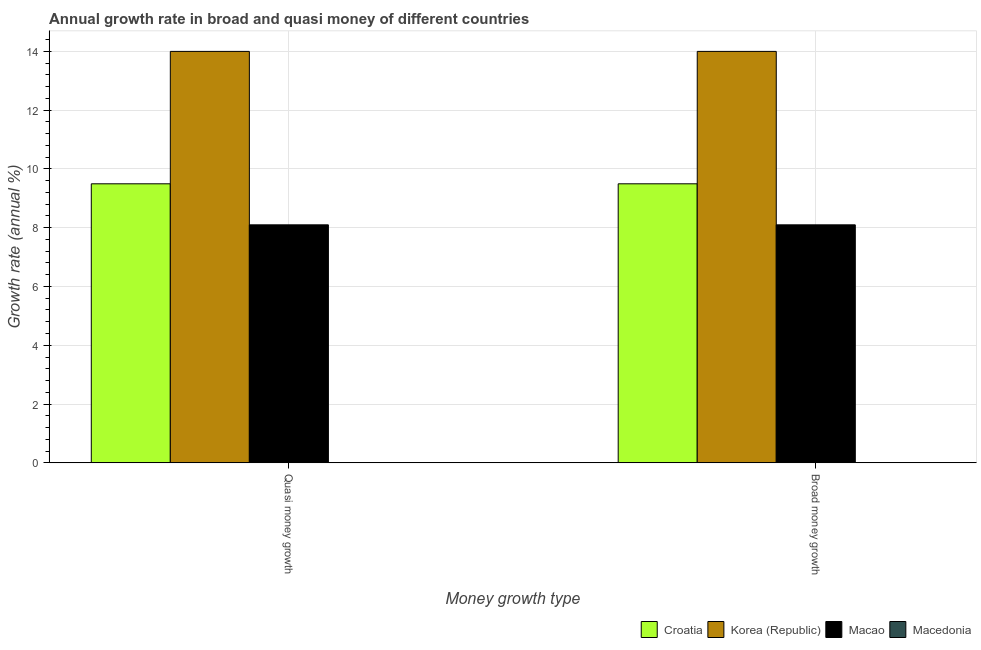How many different coloured bars are there?
Your response must be concise. 3. Are the number of bars per tick equal to the number of legend labels?
Ensure brevity in your answer.  No. Are the number of bars on each tick of the X-axis equal?
Your answer should be very brief. Yes. How many bars are there on the 2nd tick from the left?
Make the answer very short. 3. What is the label of the 1st group of bars from the left?
Ensure brevity in your answer.  Quasi money growth. What is the annual growth rate in quasi money in Macao?
Provide a succinct answer. 8.1. Across all countries, what is the maximum annual growth rate in quasi money?
Provide a succinct answer. 14. Across all countries, what is the minimum annual growth rate in quasi money?
Your answer should be compact. 0. What is the total annual growth rate in quasi money in the graph?
Offer a very short reply. 31.59. What is the difference between the annual growth rate in quasi money in Korea (Republic) and that in Macao?
Provide a succinct answer. 5.9. What is the difference between the annual growth rate in quasi money in Croatia and the annual growth rate in broad money in Macedonia?
Keep it short and to the point. 9.49. What is the average annual growth rate in quasi money per country?
Offer a terse response. 7.9. In how many countries, is the annual growth rate in broad money greater than 4.4 %?
Keep it short and to the point. 3. What is the ratio of the annual growth rate in broad money in Macao to that in Croatia?
Ensure brevity in your answer.  0.85. Is the annual growth rate in quasi money in Macao less than that in Korea (Republic)?
Keep it short and to the point. Yes. How many bars are there?
Offer a terse response. 6. What is the difference between two consecutive major ticks on the Y-axis?
Offer a terse response. 2. Does the graph contain any zero values?
Keep it short and to the point. Yes. How many legend labels are there?
Offer a very short reply. 4. How are the legend labels stacked?
Your response must be concise. Horizontal. What is the title of the graph?
Provide a succinct answer. Annual growth rate in broad and quasi money of different countries. Does "Cyprus" appear as one of the legend labels in the graph?
Ensure brevity in your answer.  No. What is the label or title of the X-axis?
Offer a terse response. Money growth type. What is the label or title of the Y-axis?
Your answer should be compact. Growth rate (annual %). What is the Growth rate (annual %) of Croatia in Quasi money growth?
Offer a terse response. 9.49. What is the Growth rate (annual %) of Korea (Republic) in Quasi money growth?
Give a very brief answer. 14. What is the Growth rate (annual %) in Macao in Quasi money growth?
Your answer should be compact. 8.1. What is the Growth rate (annual %) of Macedonia in Quasi money growth?
Ensure brevity in your answer.  0. What is the Growth rate (annual %) of Croatia in Broad money growth?
Give a very brief answer. 9.49. What is the Growth rate (annual %) of Korea (Republic) in Broad money growth?
Provide a succinct answer. 14. What is the Growth rate (annual %) of Macao in Broad money growth?
Provide a succinct answer. 8.1. What is the Growth rate (annual %) of Macedonia in Broad money growth?
Make the answer very short. 0. Across all Money growth type, what is the maximum Growth rate (annual %) in Croatia?
Your response must be concise. 9.49. Across all Money growth type, what is the maximum Growth rate (annual %) in Korea (Republic)?
Your answer should be compact. 14. Across all Money growth type, what is the maximum Growth rate (annual %) of Macao?
Give a very brief answer. 8.1. Across all Money growth type, what is the minimum Growth rate (annual %) of Croatia?
Offer a very short reply. 9.49. Across all Money growth type, what is the minimum Growth rate (annual %) of Korea (Republic)?
Provide a succinct answer. 14. Across all Money growth type, what is the minimum Growth rate (annual %) in Macao?
Provide a succinct answer. 8.1. What is the total Growth rate (annual %) in Croatia in the graph?
Keep it short and to the point. 18.99. What is the total Growth rate (annual %) of Korea (Republic) in the graph?
Give a very brief answer. 28. What is the total Growth rate (annual %) of Macao in the graph?
Ensure brevity in your answer.  16.2. What is the total Growth rate (annual %) in Macedonia in the graph?
Give a very brief answer. 0. What is the difference between the Growth rate (annual %) in Korea (Republic) in Quasi money growth and that in Broad money growth?
Offer a very short reply. 0. What is the difference between the Growth rate (annual %) of Croatia in Quasi money growth and the Growth rate (annual %) of Korea (Republic) in Broad money growth?
Give a very brief answer. -4.51. What is the difference between the Growth rate (annual %) in Croatia in Quasi money growth and the Growth rate (annual %) in Macao in Broad money growth?
Your response must be concise. 1.4. What is the difference between the Growth rate (annual %) of Korea (Republic) in Quasi money growth and the Growth rate (annual %) of Macao in Broad money growth?
Your answer should be compact. 5.9. What is the average Growth rate (annual %) in Croatia per Money growth type?
Make the answer very short. 9.49. What is the average Growth rate (annual %) in Korea (Republic) per Money growth type?
Your answer should be very brief. 14. What is the average Growth rate (annual %) of Macao per Money growth type?
Ensure brevity in your answer.  8.1. What is the difference between the Growth rate (annual %) of Croatia and Growth rate (annual %) of Korea (Republic) in Quasi money growth?
Give a very brief answer. -4.51. What is the difference between the Growth rate (annual %) in Croatia and Growth rate (annual %) in Macao in Quasi money growth?
Give a very brief answer. 1.4. What is the difference between the Growth rate (annual %) in Korea (Republic) and Growth rate (annual %) in Macao in Quasi money growth?
Your response must be concise. 5.9. What is the difference between the Growth rate (annual %) in Croatia and Growth rate (annual %) in Korea (Republic) in Broad money growth?
Keep it short and to the point. -4.51. What is the difference between the Growth rate (annual %) of Croatia and Growth rate (annual %) of Macao in Broad money growth?
Your answer should be very brief. 1.4. What is the difference between the Growth rate (annual %) of Korea (Republic) and Growth rate (annual %) of Macao in Broad money growth?
Your response must be concise. 5.9. What is the ratio of the Growth rate (annual %) in Croatia in Quasi money growth to that in Broad money growth?
Your answer should be compact. 1. What is the difference between the highest and the second highest Growth rate (annual %) in Croatia?
Your answer should be very brief. 0. What is the difference between the highest and the second highest Growth rate (annual %) of Macao?
Your answer should be compact. 0. What is the difference between the highest and the lowest Growth rate (annual %) in Croatia?
Offer a terse response. 0. What is the difference between the highest and the lowest Growth rate (annual %) of Korea (Republic)?
Give a very brief answer. 0. What is the difference between the highest and the lowest Growth rate (annual %) in Macao?
Ensure brevity in your answer.  0. 